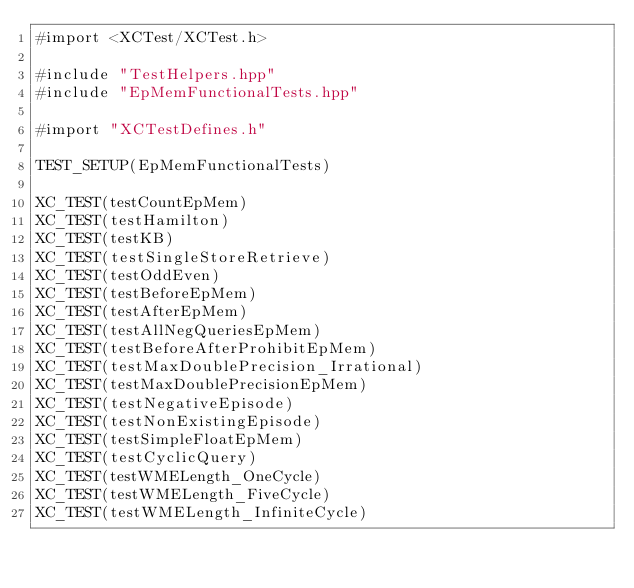<code> <loc_0><loc_0><loc_500><loc_500><_ObjectiveC_>#import <XCTest/XCTest.h>

#include "TestHelpers.hpp"
#include "EpMemFunctionalTests.hpp"

#import "XCTestDefines.h"

TEST_SETUP(EpMemFunctionalTests)

XC_TEST(testCountEpMem)
XC_TEST(testHamilton)
XC_TEST(testKB)
XC_TEST(testSingleStoreRetrieve)
XC_TEST(testOddEven)
XC_TEST(testBeforeEpMem)
XC_TEST(testAfterEpMem)
XC_TEST(testAllNegQueriesEpMem)
XC_TEST(testBeforeAfterProhibitEpMem)
XC_TEST(testMaxDoublePrecision_Irrational)
XC_TEST(testMaxDoublePrecisionEpMem)
XC_TEST(testNegativeEpisode)
XC_TEST(testNonExistingEpisode)
XC_TEST(testSimpleFloatEpMem)
XC_TEST(testCyclicQuery)
XC_TEST(testWMELength_OneCycle)
XC_TEST(testWMELength_FiveCycle)
XC_TEST(testWMELength_InfiniteCycle)</code> 